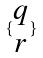Convert formula to latex. <formula><loc_0><loc_0><loc_500><loc_500>\{ \begin{matrix} q \\ r \end{matrix} \}</formula> 